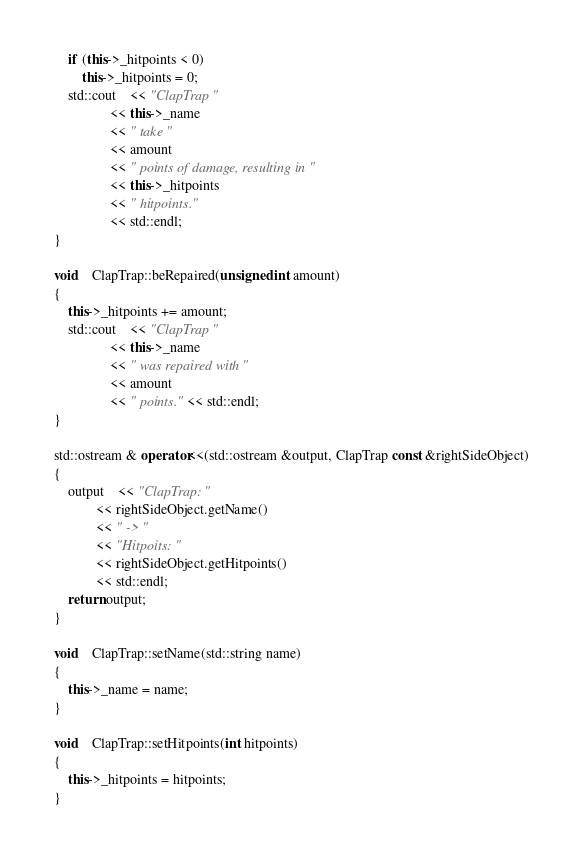Convert code to text. <code><loc_0><loc_0><loc_500><loc_500><_C++_>	if (this->_hitpoints < 0)
		this->_hitpoints = 0;
	std::cout	<< "ClapTrap "
				<< this->_name
				<< " take "
				<< amount
				<< " points of damage, resulting in "
				<< this->_hitpoints
				<< " hitpoints."
				<< std::endl;
}

void	ClapTrap::beRepaired(unsigned int amount)
{
	this->_hitpoints += amount;
	std::cout	<< "ClapTrap "
				<< this->_name
				<< " was repaired with "
				<< amount
				<< " points." << std::endl;
}

std::ostream & operator<<(std::ostream &output, ClapTrap const &rightSideObject)
{
	output	<< "ClapTrap: "
			<< rightSideObject.getName()
			<< " -> "
			<< "Hitpoits: "
			<< rightSideObject.getHitpoints()
			<< std::endl;
	return output;
}

void	ClapTrap::setName(std::string name)
{
	this->_name = name;
}

void	ClapTrap::setHitpoints(int hitpoints)
{
	this->_hitpoints = hitpoints;
}
</code> 